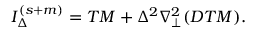Convert formula to latex. <formula><loc_0><loc_0><loc_500><loc_500>I _ { \Delta } ^ { ( s + m ) } = T M + \Delta ^ { 2 } \nabla _ { \perp } ^ { 2 } ( D T M ) .</formula> 